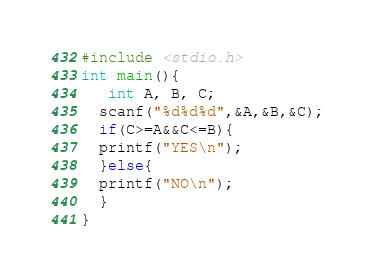Convert code to text. <code><loc_0><loc_0><loc_500><loc_500><_C_>#include <stdio.h>
int main(){
   int A, B, C;
  scanf("%d%d%d",&A,&B,&C);
  if(C>=A&&C<=B){
  printf("YES\n");
  }else{
  printf("NO\n");
  }
}</code> 